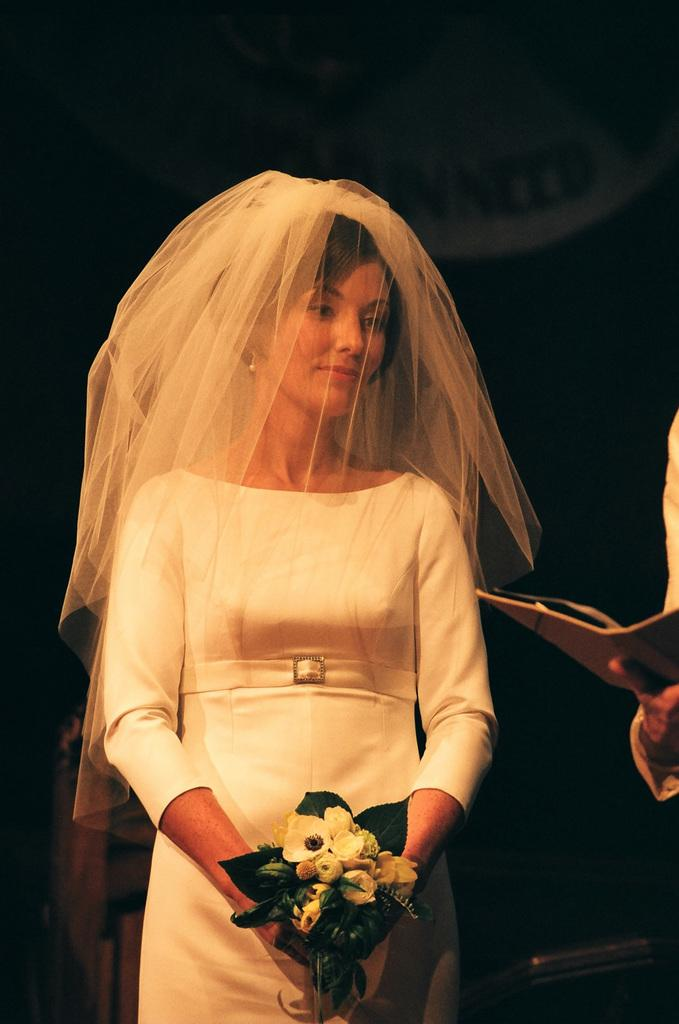What is the main subject of the image? There is a person standing in the image. What color is the person's clothing? The person is wearing white. What is the person holding in the image? The person is holding a bouquet. What is the color of the background in the image? There is a black background in the image. How does the person's sense of humor compare to that of a comedian in the image? There is no information about the person's sense of humor or the presence of a comedian in the image, so it cannot be determined from the image. 